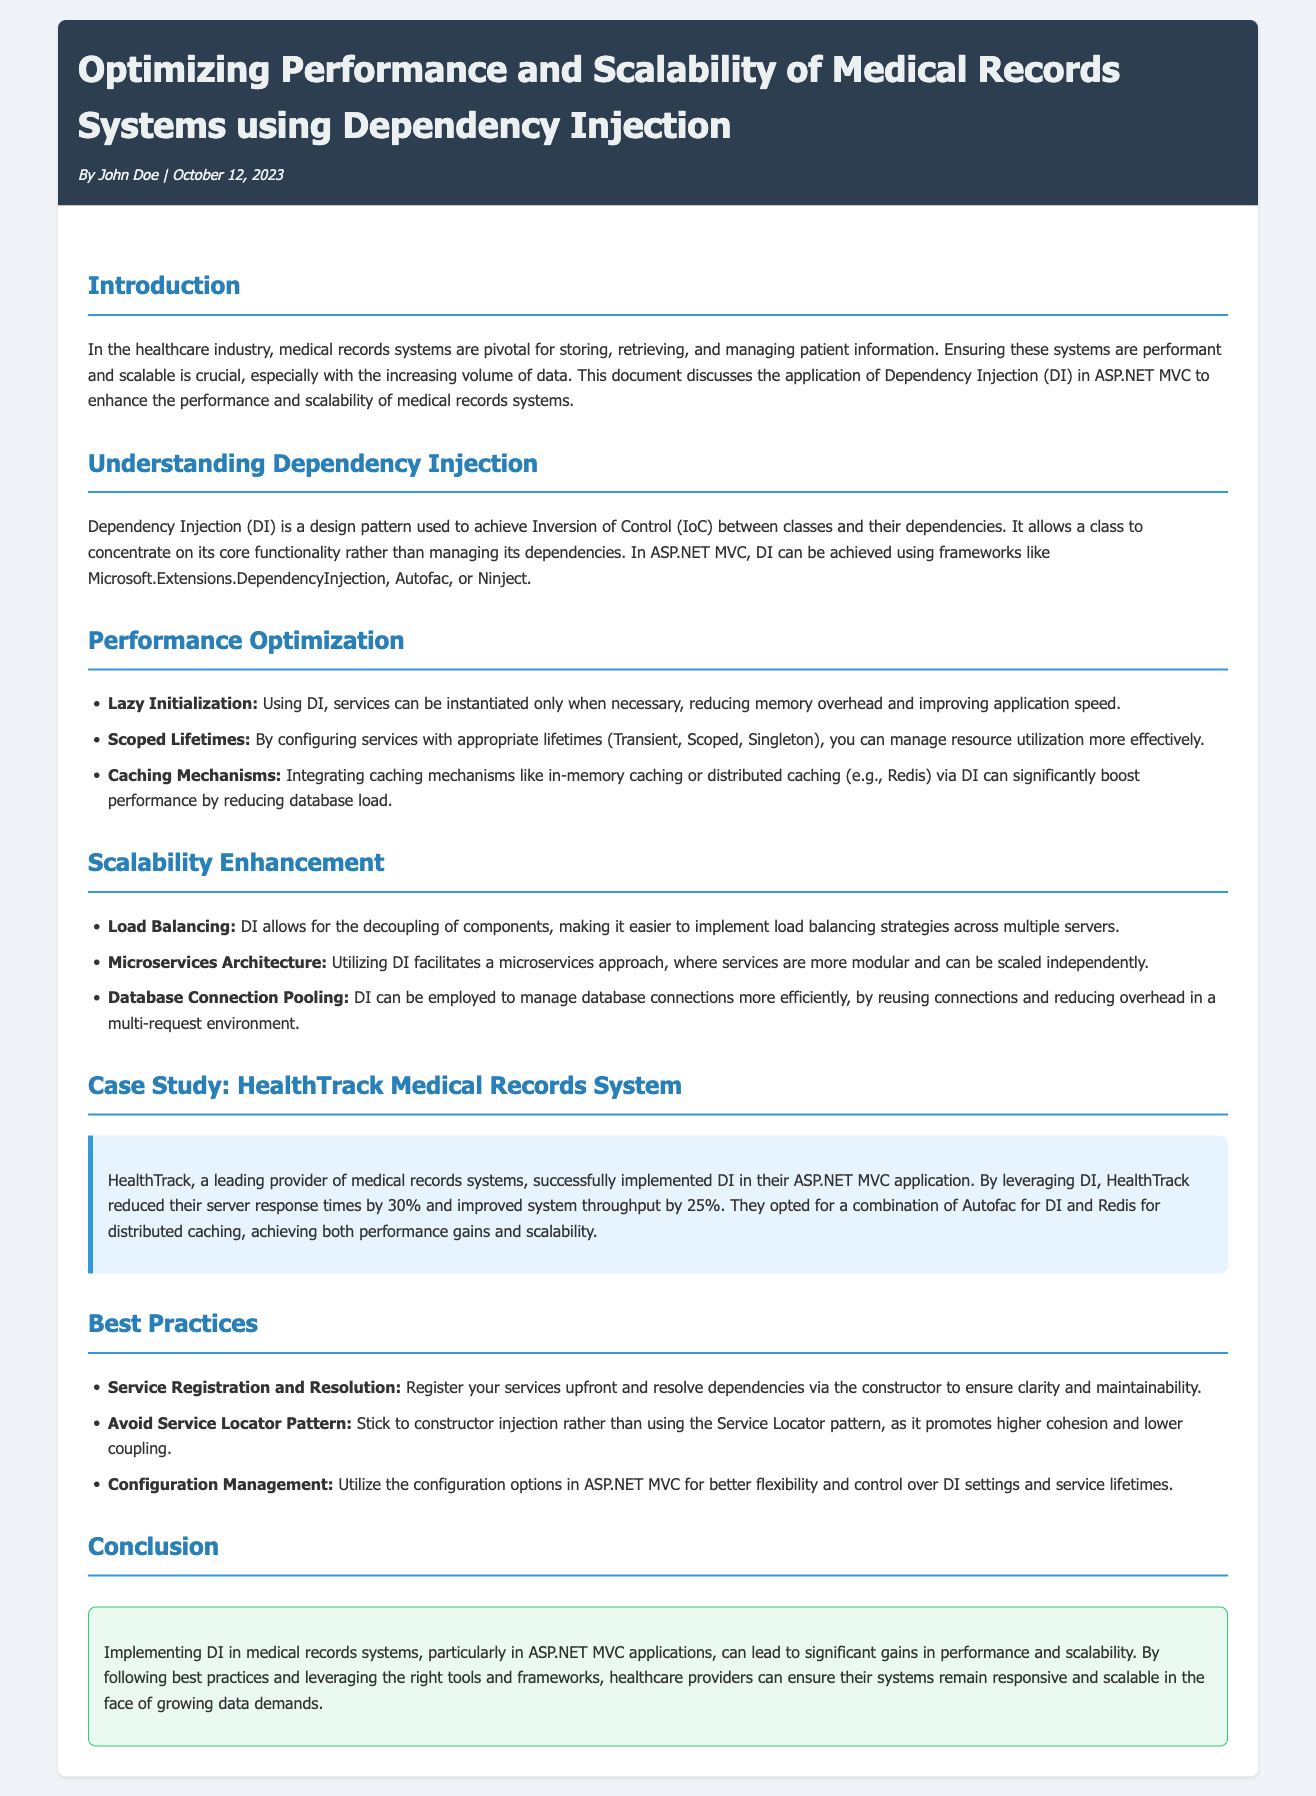What is the title of the document? The title is stated in the header section of the document.
Answer: Optimizing Performance and Scalability of Medical Records Systems using Dependency Injection Who is the author of the document? The author's name is mentioned in the header's meta section.
Answer: John Doe What type of architecture does Dependency Injection facilitate according to the document? The architecture type is mentioned under the Scalability Enhancement section.
Answer: Microservices Architecture What was the percentage reduction in server response times achieved by HealthTrack? This percentage is provided in the case study of the document.
Answer: 30% What are the three optimization techniques mentioned for performance enhancement? These techniques are listed in the Performance Optimization section.
Answer: Lazy Initialization, Scoped Lifetimes, Caching Mechanisms What should be avoided according to the Best Practices section? The document specifically advises against a certain pattern.
Answer: Service Locator Pattern In which month and year was the document published? The publication date is mentioned in the header section.
Answer: October 2023 What is the background color of the conclusion section? The background color is described in the styling of the conclusion section.
Answer: #eafaf1 What caching solution did HealthTrack choose? The specific caching solution is mentioned in the case study of the document.
Answer: Redis 